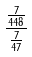<formula> <loc_0><loc_0><loc_500><loc_500>\frac { \frac { 7 } { 4 4 8 } } { \frac { 7 } { 4 7 } }</formula> 